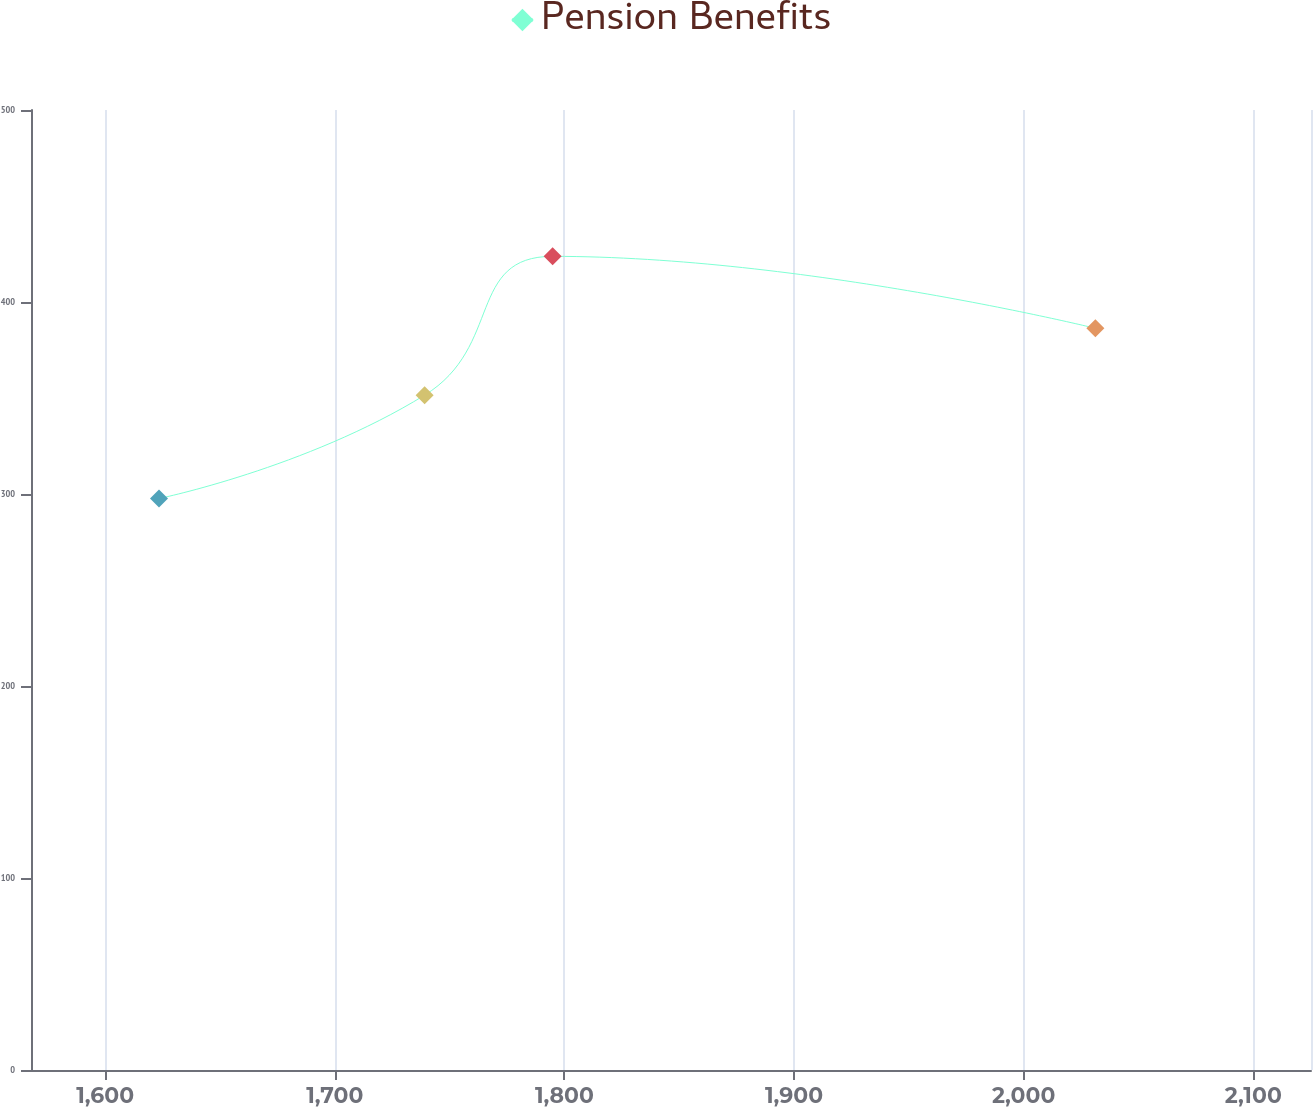Convert chart. <chart><loc_0><loc_0><loc_500><loc_500><line_chart><ecel><fcel>Pension Benefits<nl><fcel>1623.45<fcel>297.64<nl><fcel>1739.14<fcel>351.49<nl><fcel>1794.88<fcel>423.78<nl><fcel>2031.23<fcel>386.31<nl><fcel>2180.88<fcel>338.88<nl></chart> 